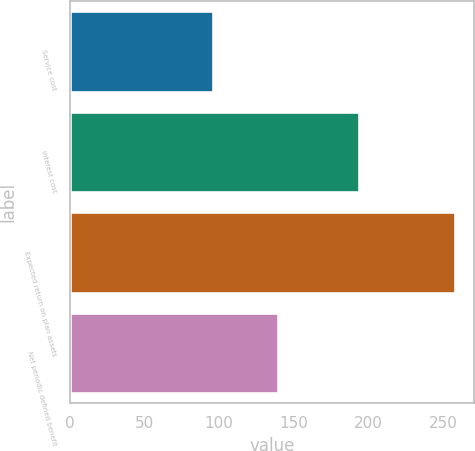<chart> <loc_0><loc_0><loc_500><loc_500><bar_chart><fcel>Service cost<fcel>Interest cost<fcel>Expected return on plan assets<fcel>Net periodic defined benefit<nl><fcel>96<fcel>194<fcel>258<fcel>139.2<nl></chart> 